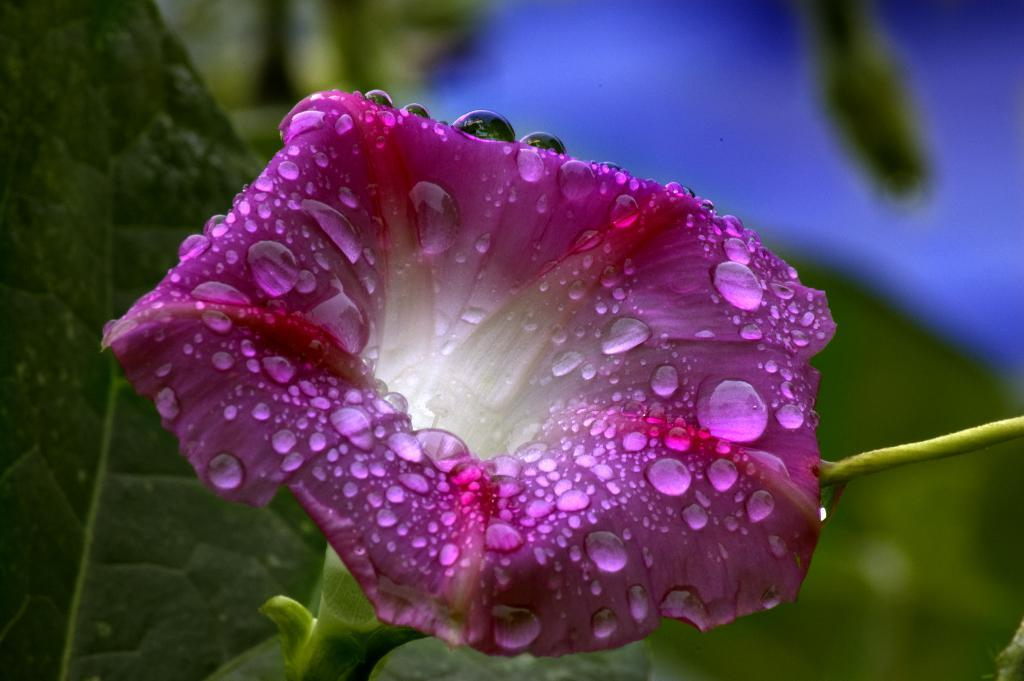What is the main subject of the image? There is a flower in the image. Can you describe the flower in more detail? The flower has droplets of water on it. What else can be seen in the background of the image? There is a green leaf in the background of the image. What type of wax is being used to shape the flower in the image? There is no wax present in the image; it features a real flower with droplets of water on it. Can you tell me how many lamps are visible in the image? There are no lamps present in the image; it only features a flower and a green leaf in the background. 